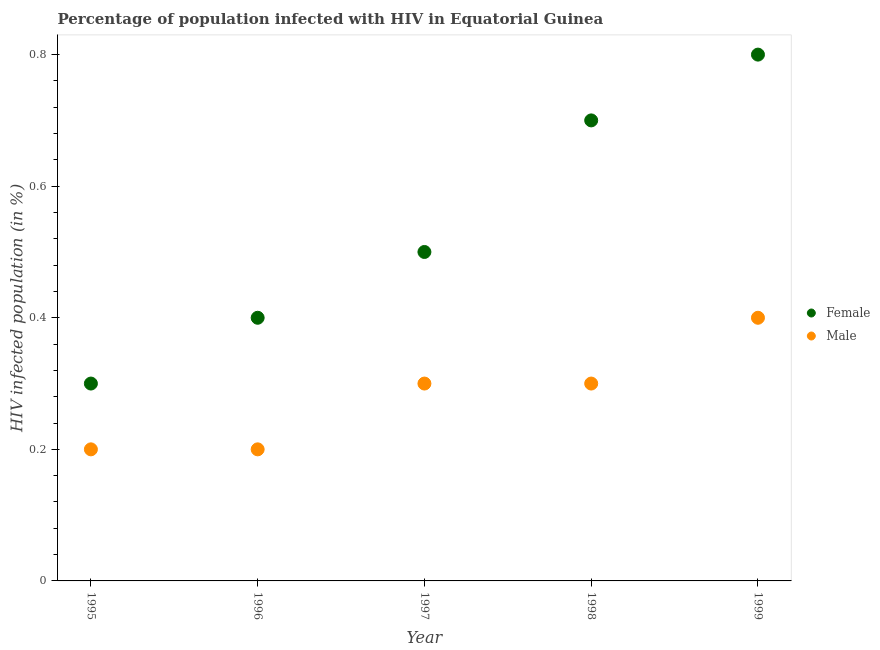How many different coloured dotlines are there?
Your answer should be compact. 2. Is the number of dotlines equal to the number of legend labels?
Your answer should be very brief. Yes. In which year was the percentage of males who are infected with hiv minimum?
Your answer should be very brief. 1995. What is the total percentage of males who are infected with hiv in the graph?
Provide a short and direct response. 1.4. What is the difference between the percentage of males who are infected with hiv in 1996 and that in 1997?
Offer a very short reply. -0.1. What is the average percentage of females who are infected with hiv per year?
Your response must be concise. 0.54. In how many years, is the percentage of males who are infected with hiv greater than 0.16 %?
Your answer should be very brief. 5. What is the ratio of the percentage of females who are infected with hiv in 1996 to that in 1999?
Make the answer very short. 0.5. What is the difference between the highest and the second highest percentage of females who are infected with hiv?
Give a very brief answer. 0.1. In how many years, is the percentage of males who are infected with hiv greater than the average percentage of males who are infected with hiv taken over all years?
Ensure brevity in your answer.  3. Is the sum of the percentage of males who are infected with hiv in 1996 and 1998 greater than the maximum percentage of females who are infected with hiv across all years?
Your answer should be compact. No. Does the percentage of males who are infected with hiv monotonically increase over the years?
Offer a very short reply. No. Is the percentage of males who are infected with hiv strictly greater than the percentage of females who are infected with hiv over the years?
Make the answer very short. No. Is the percentage of females who are infected with hiv strictly less than the percentage of males who are infected with hiv over the years?
Provide a succinct answer. No. How many dotlines are there?
Ensure brevity in your answer.  2. How many years are there in the graph?
Your answer should be very brief. 5. What is the difference between two consecutive major ticks on the Y-axis?
Provide a short and direct response. 0.2. Does the graph contain grids?
Your response must be concise. No. Where does the legend appear in the graph?
Ensure brevity in your answer.  Center right. How many legend labels are there?
Provide a short and direct response. 2. What is the title of the graph?
Ensure brevity in your answer.  Percentage of population infected with HIV in Equatorial Guinea. What is the label or title of the X-axis?
Make the answer very short. Year. What is the label or title of the Y-axis?
Your answer should be very brief. HIV infected population (in %). What is the HIV infected population (in %) in Female in 1995?
Offer a very short reply. 0.3. What is the HIV infected population (in %) of Female in 1997?
Your answer should be very brief. 0.5. What is the HIV infected population (in %) in Female in 1999?
Provide a short and direct response. 0.8. Across all years, what is the maximum HIV infected population (in %) of Female?
Ensure brevity in your answer.  0.8. Across all years, what is the maximum HIV infected population (in %) of Male?
Provide a succinct answer. 0.4. Across all years, what is the minimum HIV infected population (in %) in Female?
Your answer should be compact. 0.3. What is the difference between the HIV infected population (in %) of Female in 1995 and that in 1997?
Ensure brevity in your answer.  -0.2. What is the difference between the HIV infected population (in %) in Male in 1995 and that in 1997?
Provide a short and direct response. -0.1. What is the difference between the HIV infected population (in %) in Male in 1995 and that in 1999?
Provide a succinct answer. -0.2. What is the difference between the HIV infected population (in %) of Male in 1996 and that in 1998?
Your response must be concise. -0.1. What is the difference between the HIV infected population (in %) of Female in 1997 and that in 1998?
Give a very brief answer. -0.2. What is the difference between the HIV infected population (in %) in Male in 1997 and that in 1998?
Your answer should be very brief. 0. What is the difference between the HIV infected population (in %) in Female in 1997 and that in 1999?
Give a very brief answer. -0.3. What is the difference between the HIV infected population (in %) in Female in 1995 and the HIV infected population (in %) in Male in 1996?
Your answer should be compact. 0.1. What is the difference between the HIV infected population (in %) in Female in 1995 and the HIV infected population (in %) in Male in 1999?
Provide a succinct answer. -0.1. What is the difference between the HIV infected population (in %) in Female in 1996 and the HIV infected population (in %) in Male in 1997?
Provide a short and direct response. 0.1. What is the difference between the HIV infected population (in %) in Female in 1997 and the HIV infected population (in %) in Male in 1999?
Make the answer very short. 0.1. What is the difference between the HIV infected population (in %) of Female in 1998 and the HIV infected population (in %) of Male in 1999?
Your response must be concise. 0.3. What is the average HIV infected population (in %) in Female per year?
Your response must be concise. 0.54. What is the average HIV infected population (in %) in Male per year?
Your response must be concise. 0.28. In the year 1996, what is the difference between the HIV infected population (in %) of Female and HIV infected population (in %) of Male?
Offer a very short reply. 0.2. In the year 1997, what is the difference between the HIV infected population (in %) in Female and HIV infected population (in %) in Male?
Offer a terse response. 0.2. In the year 1998, what is the difference between the HIV infected population (in %) in Female and HIV infected population (in %) in Male?
Keep it short and to the point. 0.4. In the year 1999, what is the difference between the HIV infected population (in %) of Female and HIV infected population (in %) of Male?
Provide a short and direct response. 0.4. What is the ratio of the HIV infected population (in %) in Male in 1995 to that in 1996?
Provide a succinct answer. 1. What is the ratio of the HIV infected population (in %) in Female in 1995 to that in 1997?
Offer a terse response. 0.6. What is the ratio of the HIV infected population (in %) of Female in 1995 to that in 1998?
Provide a short and direct response. 0.43. What is the ratio of the HIV infected population (in %) of Male in 1995 to that in 1999?
Offer a very short reply. 0.5. What is the ratio of the HIV infected population (in %) of Female in 1996 to that in 1998?
Your answer should be very brief. 0.57. What is the ratio of the HIV infected population (in %) in Female in 1996 to that in 1999?
Provide a succinct answer. 0.5. What is the ratio of the HIV infected population (in %) of Male in 1996 to that in 1999?
Your answer should be very brief. 0.5. What is the ratio of the HIV infected population (in %) of Female in 1997 to that in 1998?
Keep it short and to the point. 0.71. What is the ratio of the HIV infected population (in %) of Male in 1997 to that in 1998?
Keep it short and to the point. 1. What is the difference between the highest and the lowest HIV infected population (in %) in Female?
Provide a succinct answer. 0.5. 